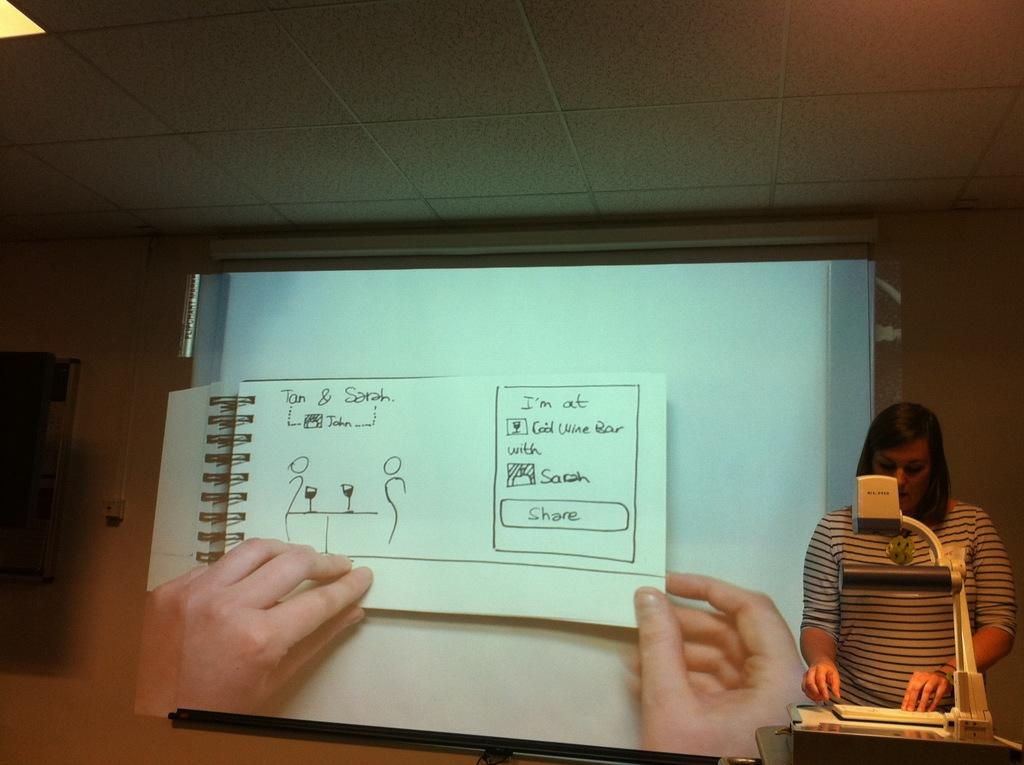<image>
Write a terse but informative summary of the picture. A woman in front of a projector screen that shows a story about Jan and Sarah. 